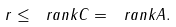Convert formula to latex. <formula><loc_0><loc_0><loc_500><loc_500>r \leq \ r a n k { C } = \ r a n k { A } .</formula> 